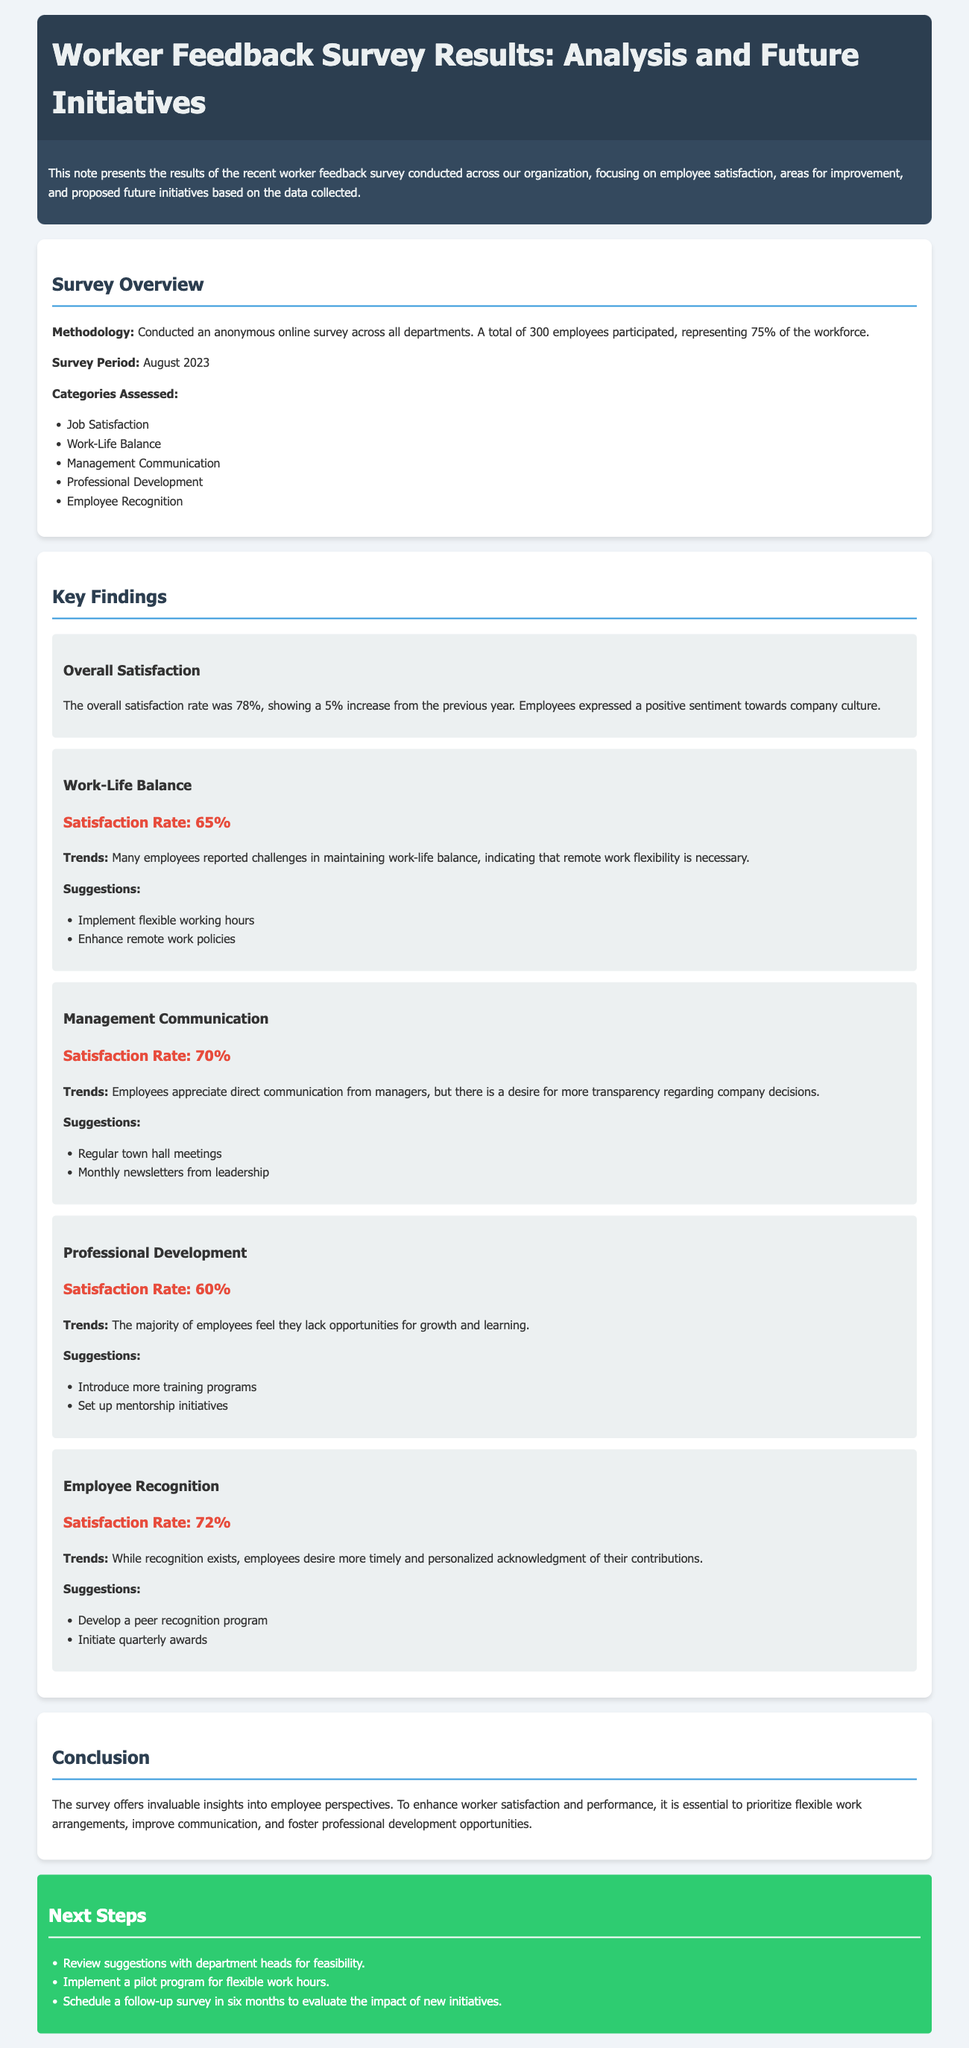What was the overall satisfaction rate? The overall satisfaction rate is a key finding that reflects employee sentiment, which increased from the previous year.
Answer: 78% When was the survey conducted? The survey period is stated in the document, indicating when the feedback was gathered from employees.
Answer: August 2023 What percentage of employees participated in the survey? This percentage reflects the level of engagement from the workforce in the survey process.
Answer: 75% What was the satisfaction rate for Work-Life Balance? This is another key finding that highlights employee perspectives on managing their professional and personal lives.
Answer: 65% What is one suggestion for improving Management Communication? Suggestions are provided in the survey results for enhancing management practices based on employee feedback.
Answer: Regular town hall meetings What trend is indicated about Professional Development? The trends reflect employee sentiments regarding their opportunities in the workplace, which is crucial for talent retention.
Answer: Lack of opportunities for growth What is a key suggestion for Employee Recognition? The document includes suggestions aimed at enhancing recognition among employees for their contributions.
Answer: Develop a peer recognition program What are the next steps mentioned in the document? The next steps provide a forward-looking plan based on the survey results and suggestions made.
Answer: Review suggestions with department heads for feasibility 